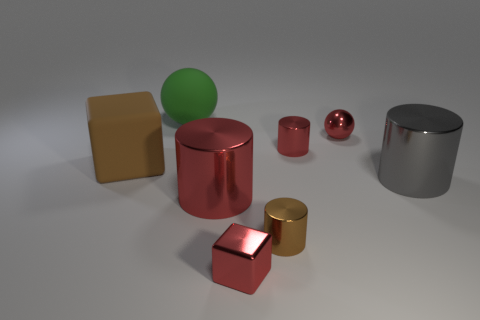Is there anything else that is the same color as the large matte ball?
Offer a very short reply. No. There is a red thing that is the same shape as the brown matte object; what is its material?
Your response must be concise. Metal. What number of other objects are there of the same size as the green thing?
Provide a succinct answer. 3. What size is the shiny cylinder that is the same color as the rubber block?
Provide a short and direct response. Small. Does the big metal thing to the left of the gray metal thing have the same shape as the tiny brown object?
Provide a succinct answer. Yes. How many other objects are there of the same shape as the brown matte object?
Make the answer very short. 1. The brown object that is behind the big gray thing has what shape?
Provide a short and direct response. Cube. Are there any tiny cyan cylinders that have the same material as the red cube?
Make the answer very short. No. Is the color of the tiny shiny cylinder in front of the gray cylinder the same as the tiny sphere?
Offer a terse response. No. What is the size of the rubber sphere?
Your answer should be very brief. Large. 